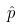<formula> <loc_0><loc_0><loc_500><loc_500>\hat { p }</formula> 